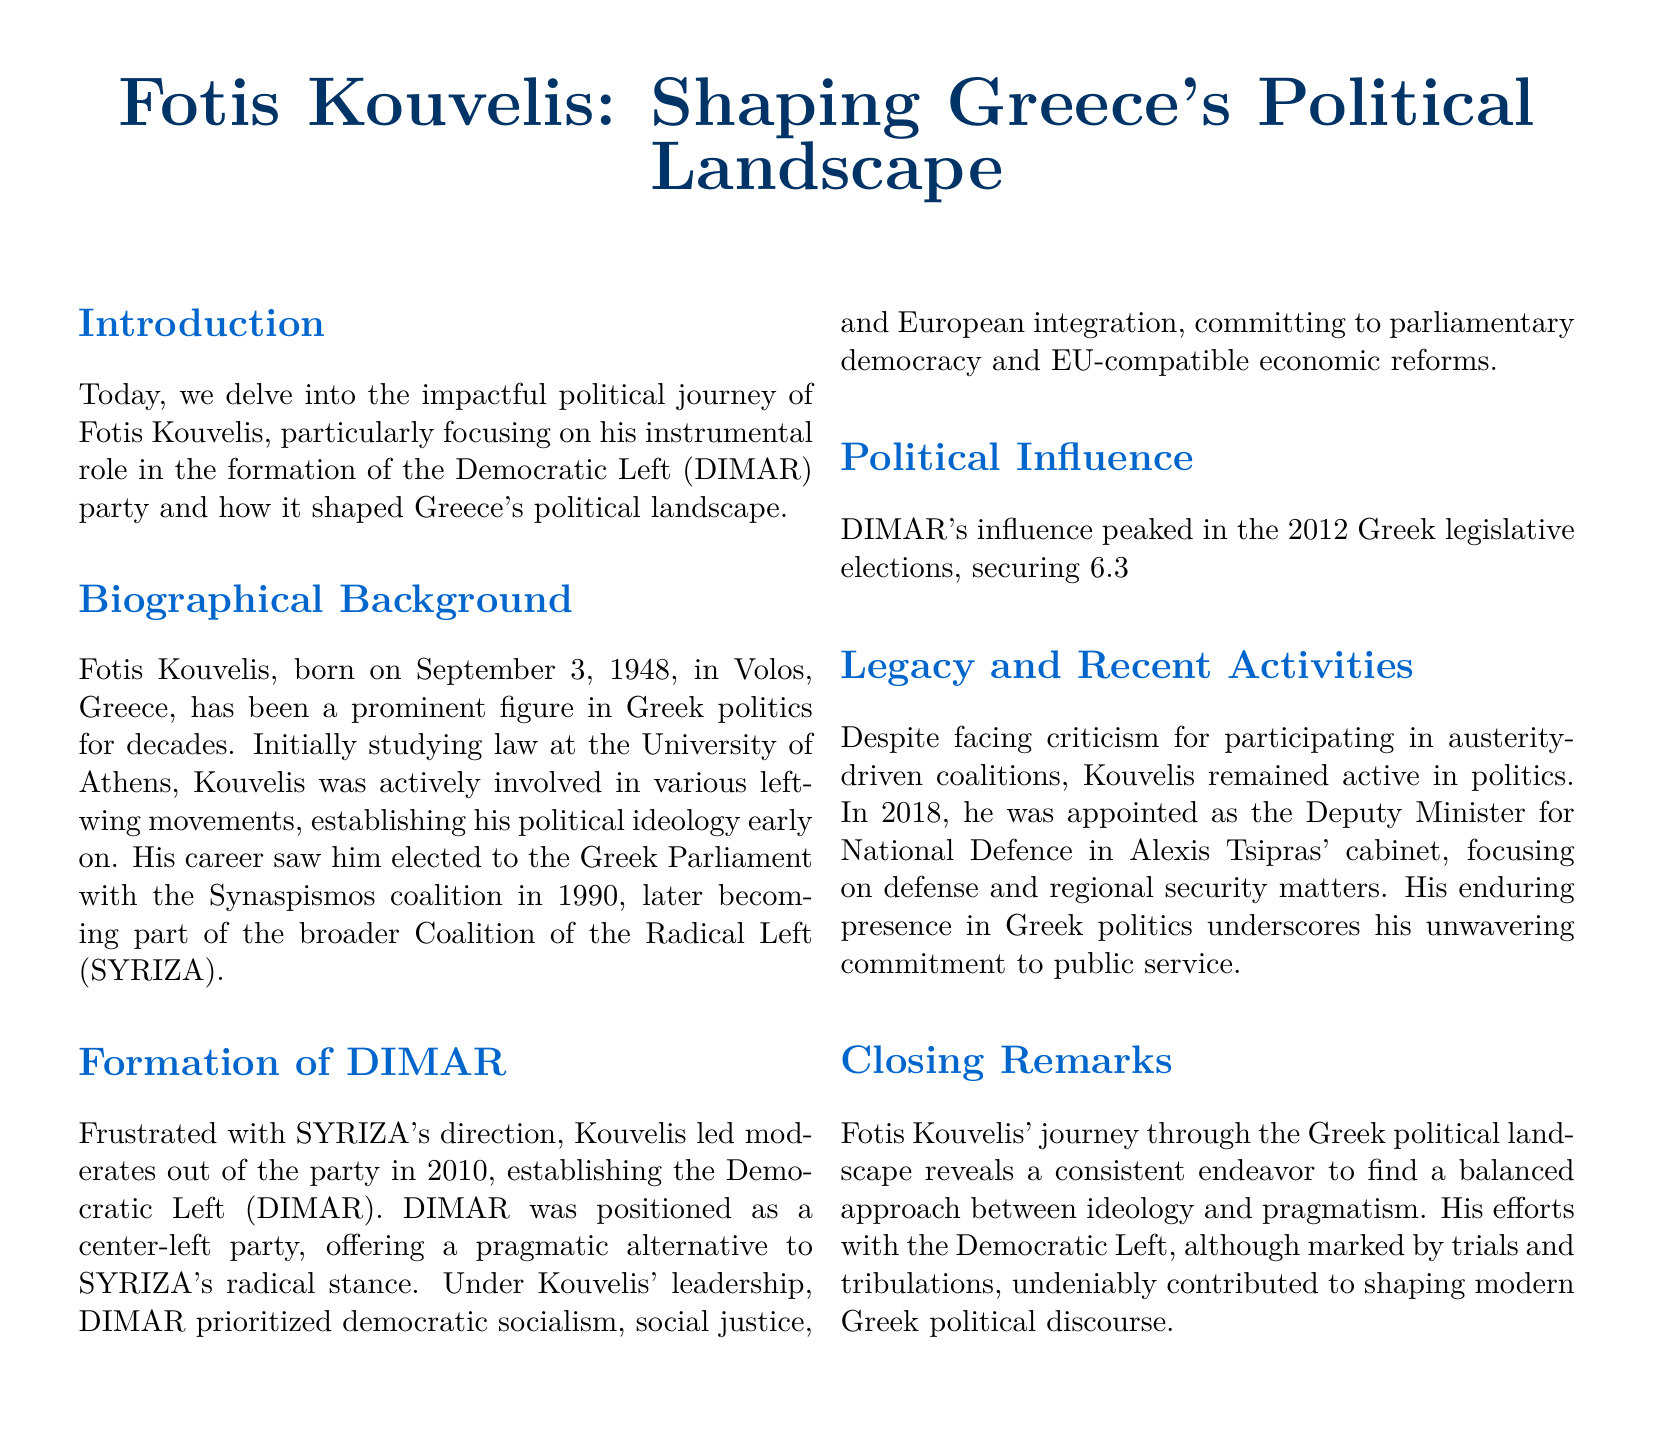What year was Fotis Kouvelis born? The document states that Fotis Kouvelis was born on September 3, 1948.
Answer: 1948 What party did Kouvelis help form in 2010? The document mentions that Kouvelis led moderates out of SYRIZA to establish the Democratic Left (DIMAR).
Answer: Democratic Left (DIMAR) What percentage of the vote did DIMAR secure in the 2012 elections? The document notes that DIMAR secured 6.3% of the vote in the 2012 Greek legislative elections.
Answer: 6.3% What ministerial position did Kouvelis hold in 2018? The document specifies that he was appointed as the Deputy Minister for National Defence in 2018.
Answer: Deputy Minister for National Defence How many parliamentary seats did DIMAR win in the 2012 elections? The document states that DIMAR won 17 parliamentary seats in the 2012 elections.
Answer: 17 What ideological stance did DIMAR prioritize? The document explains that DIMAR prioritized democratic socialism.
Answer: democratic socialism What was Kouvelis' political affiliation before forming DIMAR? The document indicates that Kouvelis was part of the broader Coalition of the Radical Left (SYRIZA) before forming DIMAR.
Answer: SYRIZA What area did Kouvelis focus on during his term as Deputy Minister? The document mentions he focused on defense and regional security matters.
Answer: defense and regional security 